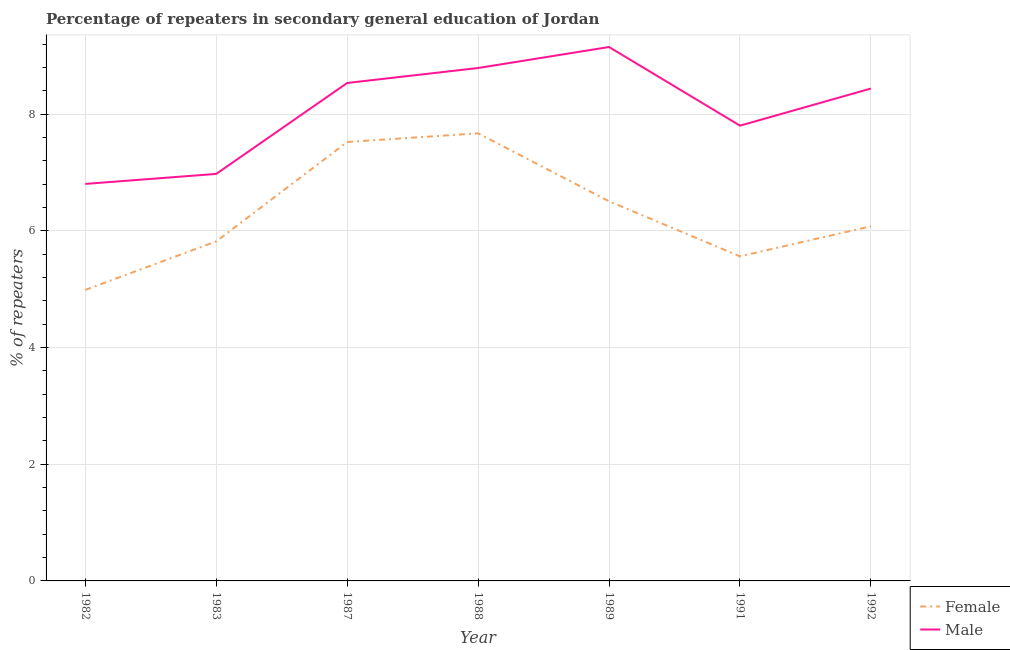How many different coloured lines are there?
Make the answer very short. 2. Does the line corresponding to percentage of female repeaters intersect with the line corresponding to percentage of male repeaters?
Provide a succinct answer. No. What is the percentage of female repeaters in 1982?
Your answer should be very brief. 4.99. Across all years, what is the maximum percentage of female repeaters?
Provide a short and direct response. 7.67. Across all years, what is the minimum percentage of female repeaters?
Your answer should be very brief. 4.99. In which year was the percentage of female repeaters minimum?
Keep it short and to the point. 1982. What is the total percentage of female repeaters in the graph?
Your answer should be compact. 44.16. What is the difference between the percentage of female repeaters in 1989 and that in 1992?
Give a very brief answer. 0.43. What is the difference between the percentage of female repeaters in 1991 and the percentage of male repeaters in 1992?
Offer a very short reply. -2.88. What is the average percentage of male repeaters per year?
Your answer should be very brief. 8.07. In the year 1989, what is the difference between the percentage of female repeaters and percentage of male repeaters?
Offer a very short reply. -2.64. In how many years, is the percentage of male repeaters greater than 6 %?
Provide a succinct answer. 7. What is the ratio of the percentage of female repeaters in 1987 to that in 1988?
Your response must be concise. 0.98. Is the percentage of male repeaters in 1983 less than that in 1987?
Ensure brevity in your answer.  Yes. What is the difference between the highest and the second highest percentage of female repeaters?
Offer a very short reply. 0.15. What is the difference between the highest and the lowest percentage of female repeaters?
Ensure brevity in your answer.  2.68. Is the sum of the percentage of male repeaters in 1991 and 1992 greater than the maximum percentage of female repeaters across all years?
Offer a very short reply. Yes. Does the percentage of male repeaters monotonically increase over the years?
Make the answer very short. No. Is the percentage of female repeaters strictly greater than the percentage of male repeaters over the years?
Give a very brief answer. No. Is the percentage of male repeaters strictly less than the percentage of female repeaters over the years?
Ensure brevity in your answer.  No. What is the difference between two consecutive major ticks on the Y-axis?
Make the answer very short. 2. How many legend labels are there?
Provide a succinct answer. 2. What is the title of the graph?
Your answer should be compact. Percentage of repeaters in secondary general education of Jordan. Does "Female population" appear as one of the legend labels in the graph?
Keep it short and to the point. No. What is the label or title of the X-axis?
Your answer should be very brief. Year. What is the label or title of the Y-axis?
Your answer should be compact. % of repeaters. What is the % of repeaters of Female in 1982?
Offer a terse response. 4.99. What is the % of repeaters in Male in 1982?
Give a very brief answer. 6.81. What is the % of repeaters in Female in 1983?
Provide a short and direct response. 5.82. What is the % of repeaters of Male in 1983?
Provide a succinct answer. 6.98. What is the % of repeaters of Female in 1987?
Your answer should be very brief. 7.52. What is the % of repeaters of Male in 1987?
Ensure brevity in your answer.  8.54. What is the % of repeaters in Female in 1988?
Your response must be concise. 7.67. What is the % of repeaters of Male in 1988?
Offer a terse response. 8.79. What is the % of repeaters in Female in 1989?
Provide a succinct answer. 6.51. What is the % of repeaters of Male in 1989?
Your answer should be very brief. 9.15. What is the % of repeaters of Female in 1991?
Ensure brevity in your answer.  5.56. What is the % of repeaters of Male in 1991?
Provide a succinct answer. 7.8. What is the % of repeaters of Female in 1992?
Give a very brief answer. 6.08. What is the % of repeaters in Male in 1992?
Keep it short and to the point. 8.44. Across all years, what is the maximum % of repeaters of Female?
Ensure brevity in your answer.  7.67. Across all years, what is the maximum % of repeaters in Male?
Your answer should be compact. 9.15. Across all years, what is the minimum % of repeaters in Female?
Offer a terse response. 4.99. Across all years, what is the minimum % of repeaters of Male?
Keep it short and to the point. 6.81. What is the total % of repeaters of Female in the graph?
Your answer should be very brief. 44.16. What is the total % of repeaters in Male in the graph?
Give a very brief answer. 56.5. What is the difference between the % of repeaters of Female in 1982 and that in 1983?
Make the answer very short. -0.83. What is the difference between the % of repeaters in Male in 1982 and that in 1983?
Make the answer very short. -0.17. What is the difference between the % of repeaters in Female in 1982 and that in 1987?
Keep it short and to the point. -2.54. What is the difference between the % of repeaters of Male in 1982 and that in 1987?
Make the answer very short. -1.73. What is the difference between the % of repeaters of Female in 1982 and that in 1988?
Keep it short and to the point. -2.68. What is the difference between the % of repeaters in Male in 1982 and that in 1988?
Offer a terse response. -1.99. What is the difference between the % of repeaters of Female in 1982 and that in 1989?
Provide a succinct answer. -1.52. What is the difference between the % of repeaters in Male in 1982 and that in 1989?
Make the answer very short. -2.35. What is the difference between the % of repeaters of Female in 1982 and that in 1991?
Give a very brief answer. -0.58. What is the difference between the % of repeaters of Male in 1982 and that in 1991?
Provide a short and direct response. -1. What is the difference between the % of repeaters of Female in 1982 and that in 1992?
Provide a short and direct response. -1.09. What is the difference between the % of repeaters of Male in 1982 and that in 1992?
Your answer should be compact. -1.63. What is the difference between the % of repeaters in Female in 1983 and that in 1987?
Provide a short and direct response. -1.7. What is the difference between the % of repeaters of Male in 1983 and that in 1987?
Your answer should be very brief. -1.56. What is the difference between the % of repeaters in Female in 1983 and that in 1988?
Your response must be concise. -1.85. What is the difference between the % of repeaters of Male in 1983 and that in 1988?
Provide a succinct answer. -1.82. What is the difference between the % of repeaters of Female in 1983 and that in 1989?
Keep it short and to the point. -0.69. What is the difference between the % of repeaters in Male in 1983 and that in 1989?
Offer a very short reply. -2.17. What is the difference between the % of repeaters of Female in 1983 and that in 1991?
Provide a short and direct response. 0.26. What is the difference between the % of repeaters in Male in 1983 and that in 1991?
Give a very brief answer. -0.83. What is the difference between the % of repeaters in Female in 1983 and that in 1992?
Offer a very short reply. -0.26. What is the difference between the % of repeaters of Male in 1983 and that in 1992?
Offer a terse response. -1.46. What is the difference between the % of repeaters in Female in 1987 and that in 1988?
Make the answer very short. -0.15. What is the difference between the % of repeaters in Male in 1987 and that in 1988?
Offer a terse response. -0.26. What is the difference between the % of repeaters in Female in 1987 and that in 1989?
Keep it short and to the point. 1.02. What is the difference between the % of repeaters of Male in 1987 and that in 1989?
Make the answer very short. -0.62. What is the difference between the % of repeaters in Female in 1987 and that in 1991?
Provide a succinct answer. 1.96. What is the difference between the % of repeaters of Male in 1987 and that in 1991?
Give a very brief answer. 0.73. What is the difference between the % of repeaters of Female in 1987 and that in 1992?
Make the answer very short. 1.44. What is the difference between the % of repeaters of Male in 1987 and that in 1992?
Ensure brevity in your answer.  0.1. What is the difference between the % of repeaters of Female in 1988 and that in 1989?
Offer a very short reply. 1.17. What is the difference between the % of repeaters in Male in 1988 and that in 1989?
Provide a short and direct response. -0.36. What is the difference between the % of repeaters in Female in 1988 and that in 1991?
Offer a very short reply. 2.11. What is the difference between the % of repeaters in Male in 1988 and that in 1991?
Make the answer very short. 0.99. What is the difference between the % of repeaters of Female in 1988 and that in 1992?
Keep it short and to the point. 1.59. What is the difference between the % of repeaters of Male in 1988 and that in 1992?
Make the answer very short. 0.35. What is the difference between the % of repeaters of Female in 1989 and that in 1991?
Offer a very short reply. 0.94. What is the difference between the % of repeaters of Male in 1989 and that in 1991?
Provide a succinct answer. 1.35. What is the difference between the % of repeaters of Female in 1989 and that in 1992?
Ensure brevity in your answer.  0.43. What is the difference between the % of repeaters in Male in 1989 and that in 1992?
Give a very brief answer. 0.71. What is the difference between the % of repeaters in Female in 1991 and that in 1992?
Your answer should be compact. -0.52. What is the difference between the % of repeaters of Male in 1991 and that in 1992?
Your response must be concise. -0.64. What is the difference between the % of repeaters in Female in 1982 and the % of repeaters in Male in 1983?
Your answer should be compact. -1.99. What is the difference between the % of repeaters in Female in 1982 and the % of repeaters in Male in 1987?
Your response must be concise. -3.55. What is the difference between the % of repeaters in Female in 1982 and the % of repeaters in Male in 1988?
Your answer should be very brief. -3.8. What is the difference between the % of repeaters of Female in 1982 and the % of repeaters of Male in 1989?
Your response must be concise. -4.16. What is the difference between the % of repeaters of Female in 1982 and the % of repeaters of Male in 1991?
Provide a succinct answer. -2.82. What is the difference between the % of repeaters of Female in 1982 and the % of repeaters of Male in 1992?
Your answer should be compact. -3.45. What is the difference between the % of repeaters in Female in 1983 and the % of repeaters in Male in 1987?
Ensure brevity in your answer.  -2.72. What is the difference between the % of repeaters in Female in 1983 and the % of repeaters in Male in 1988?
Provide a short and direct response. -2.97. What is the difference between the % of repeaters of Female in 1983 and the % of repeaters of Male in 1989?
Provide a succinct answer. -3.33. What is the difference between the % of repeaters in Female in 1983 and the % of repeaters in Male in 1991?
Keep it short and to the point. -1.98. What is the difference between the % of repeaters in Female in 1983 and the % of repeaters in Male in 1992?
Ensure brevity in your answer.  -2.62. What is the difference between the % of repeaters in Female in 1987 and the % of repeaters in Male in 1988?
Offer a very short reply. -1.27. What is the difference between the % of repeaters of Female in 1987 and the % of repeaters of Male in 1989?
Your answer should be compact. -1.63. What is the difference between the % of repeaters in Female in 1987 and the % of repeaters in Male in 1991?
Your answer should be very brief. -0.28. What is the difference between the % of repeaters of Female in 1987 and the % of repeaters of Male in 1992?
Keep it short and to the point. -0.92. What is the difference between the % of repeaters in Female in 1988 and the % of repeaters in Male in 1989?
Keep it short and to the point. -1.48. What is the difference between the % of repeaters in Female in 1988 and the % of repeaters in Male in 1991?
Provide a short and direct response. -0.13. What is the difference between the % of repeaters of Female in 1988 and the % of repeaters of Male in 1992?
Provide a succinct answer. -0.77. What is the difference between the % of repeaters in Female in 1989 and the % of repeaters in Male in 1991?
Make the answer very short. -1.3. What is the difference between the % of repeaters of Female in 1989 and the % of repeaters of Male in 1992?
Provide a short and direct response. -1.93. What is the difference between the % of repeaters in Female in 1991 and the % of repeaters in Male in 1992?
Your answer should be very brief. -2.88. What is the average % of repeaters in Female per year?
Make the answer very short. 6.31. What is the average % of repeaters in Male per year?
Make the answer very short. 8.07. In the year 1982, what is the difference between the % of repeaters in Female and % of repeaters in Male?
Keep it short and to the point. -1.82. In the year 1983, what is the difference between the % of repeaters of Female and % of repeaters of Male?
Your answer should be compact. -1.16. In the year 1987, what is the difference between the % of repeaters in Female and % of repeaters in Male?
Ensure brevity in your answer.  -1.01. In the year 1988, what is the difference between the % of repeaters of Female and % of repeaters of Male?
Provide a short and direct response. -1.12. In the year 1989, what is the difference between the % of repeaters in Female and % of repeaters in Male?
Keep it short and to the point. -2.64. In the year 1991, what is the difference between the % of repeaters of Female and % of repeaters of Male?
Make the answer very short. -2.24. In the year 1992, what is the difference between the % of repeaters of Female and % of repeaters of Male?
Provide a short and direct response. -2.36. What is the ratio of the % of repeaters of Male in 1982 to that in 1983?
Keep it short and to the point. 0.98. What is the ratio of the % of repeaters in Female in 1982 to that in 1987?
Your answer should be compact. 0.66. What is the ratio of the % of repeaters of Male in 1982 to that in 1987?
Provide a succinct answer. 0.8. What is the ratio of the % of repeaters in Female in 1982 to that in 1988?
Your answer should be compact. 0.65. What is the ratio of the % of repeaters in Male in 1982 to that in 1988?
Offer a very short reply. 0.77. What is the ratio of the % of repeaters of Female in 1982 to that in 1989?
Provide a succinct answer. 0.77. What is the ratio of the % of repeaters of Male in 1982 to that in 1989?
Offer a terse response. 0.74. What is the ratio of the % of repeaters in Female in 1982 to that in 1991?
Provide a succinct answer. 0.9. What is the ratio of the % of repeaters of Male in 1982 to that in 1991?
Your response must be concise. 0.87. What is the ratio of the % of repeaters of Female in 1982 to that in 1992?
Offer a terse response. 0.82. What is the ratio of the % of repeaters in Male in 1982 to that in 1992?
Ensure brevity in your answer.  0.81. What is the ratio of the % of repeaters of Female in 1983 to that in 1987?
Keep it short and to the point. 0.77. What is the ratio of the % of repeaters of Male in 1983 to that in 1987?
Offer a terse response. 0.82. What is the ratio of the % of repeaters in Female in 1983 to that in 1988?
Your response must be concise. 0.76. What is the ratio of the % of repeaters of Male in 1983 to that in 1988?
Your answer should be very brief. 0.79. What is the ratio of the % of repeaters of Female in 1983 to that in 1989?
Provide a short and direct response. 0.89. What is the ratio of the % of repeaters of Male in 1983 to that in 1989?
Keep it short and to the point. 0.76. What is the ratio of the % of repeaters of Female in 1983 to that in 1991?
Offer a terse response. 1.05. What is the ratio of the % of repeaters in Male in 1983 to that in 1991?
Keep it short and to the point. 0.89. What is the ratio of the % of repeaters of Female in 1983 to that in 1992?
Your response must be concise. 0.96. What is the ratio of the % of repeaters in Male in 1983 to that in 1992?
Offer a very short reply. 0.83. What is the ratio of the % of repeaters in Female in 1987 to that in 1988?
Your answer should be compact. 0.98. What is the ratio of the % of repeaters in Male in 1987 to that in 1988?
Make the answer very short. 0.97. What is the ratio of the % of repeaters of Female in 1987 to that in 1989?
Ensure brevity in your answer.  1.16. What is the ratio of the % of repeaters of Male in 1987 to that in 1989?
Make the answer very short. 0.93. What is the ratio of the % of repeaters in Female in 1987 to that in 1991?
Your answer should be compact. 1.35. What is the ratio of the % of repeaters in Male in 1987 to that in 1991?
Your answer should be compact. 1.09. What is the ratio of the % of repeaters in Female in 1987 to that in 1992?
Ensure brevity in your answer.  1.24. What is the ratio of the % of repeaters of Male in 1987 to that in 1992?
Keep it short and to the point. 1.01. What is the ratio of the % of repeaters of Female in 1988 to that in 1989?
Provide a short and direct response. 1.18. What is the ratio of the % of repeaters of Male in 1988 to that in 1989?
Provide a short and direct response. 0.96. What is the ratio of the % of repeaters of Female in 1988 to that in 1991?
Your answer should be compact. 1.38. What is the ratio of the % of repeaters of Male in 1988 to that in 1991?
Provide a short and direct response. 1.13. What is the ratio of the % of repeaters of Female in 1988 to that in 1992?
Your response must be concise. 1.26. What is the ratio of the % of repeaters of Male in 1988 to that in 1992?
Make the answer very short. 1.04. What is the ratio of the % of repeaters in Female in 1989 to that in 1991?
Ensure brevity in your answer.  1.17. What is the ratio of the % of repeaters in Male in 1989 to that in 1991?
Your answer should be compact. 1.17. What is the ratio of the % of repeaters of Female in 1989 to that in 1992?
Provide a short and direct response. 1.07. What is the ratio of the % of repeaters of Male in 1989 to that in 1992?
Your answer should be very brief. 1.08. What is the ratio of the % of repeaters in Female in 1991 to that in 1992?
Offer a terse response. 0.92. What is the ratio of the % of repeaters in Male in 1991 to that in 1992?
Offer a very short reply. 0.92. What is the difference between the highest and the second highest % of repeaters of Female?
Provide a short and direct response. 0.15. What is the difference between the highest and the second highest % of repeaters in Male?
Your answer should be very brief. 0.36. What is the difference between the highest and the lowest % of repeaters in Female?
Offer a terse response. 2.68. What is the difference between the highest and the lowest % of repeaters of Male?
Provide a short and direct response. 2.35. 